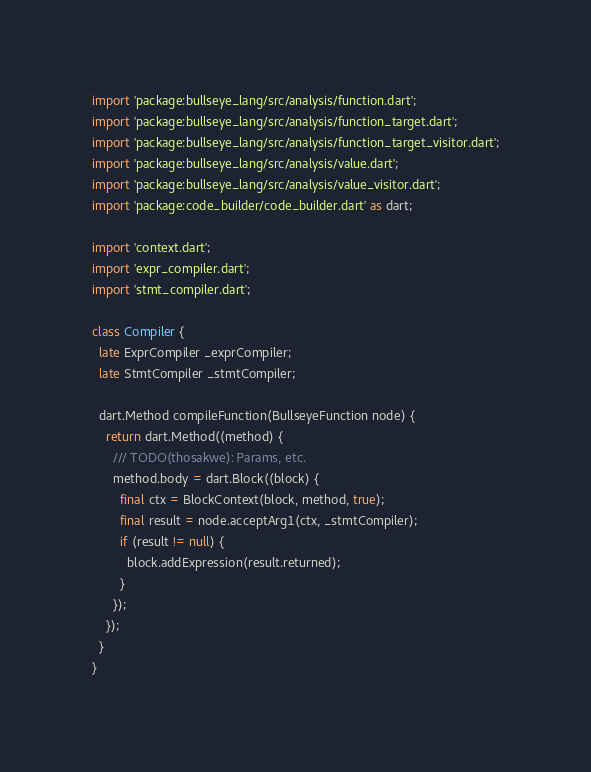Convert code to text. <code><loc_0><loc_0><loc_500><loc_500><_Dart_>import 'package:bullseye_lang/src/analysis/function.dart';
import 'package:bullseye_lang/src/analysis/function_target.dart';
import 'package:bullseye_lang/src/analysis/function_target_visitor.dart';
import 'package:bullseye_lang/src/analysis/value.dart';
import 'package:bullseye_lang/src/analysis/value_visitor.dart';
import 'package:code_builder/code_builder.dart' as dart;

import 'context.dart';
import 'expr_compiler.dart';
import 'stmt_compiler.dart';

class Compiler {
  late ExprCompiler _exprCompiler;
  late StmtCompiler _stmtCompiler;

  dart.Method compileFunction(BullseyeFunction node) {
    return dart.Method((method) {
      /// TODO(thosakwe): Params, etc.
      method.body = dart.Block((block) {
        final ctx = BlockContext(block, method, true);
        final result = node.acceptArg1(ctx, _stmtCompiler);
        if (result != null) {
          block.addExpression(result.returned);
        }
      });
    });
  }
}
</code> 